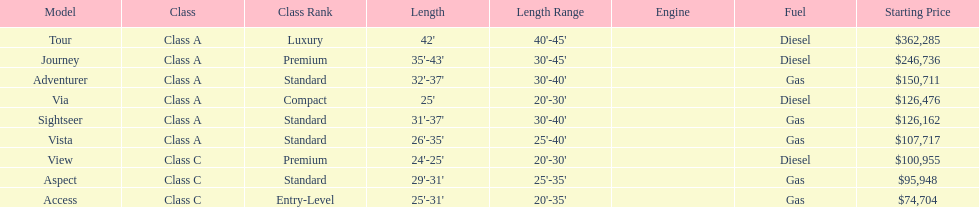What is the total number of class a models? 6. 